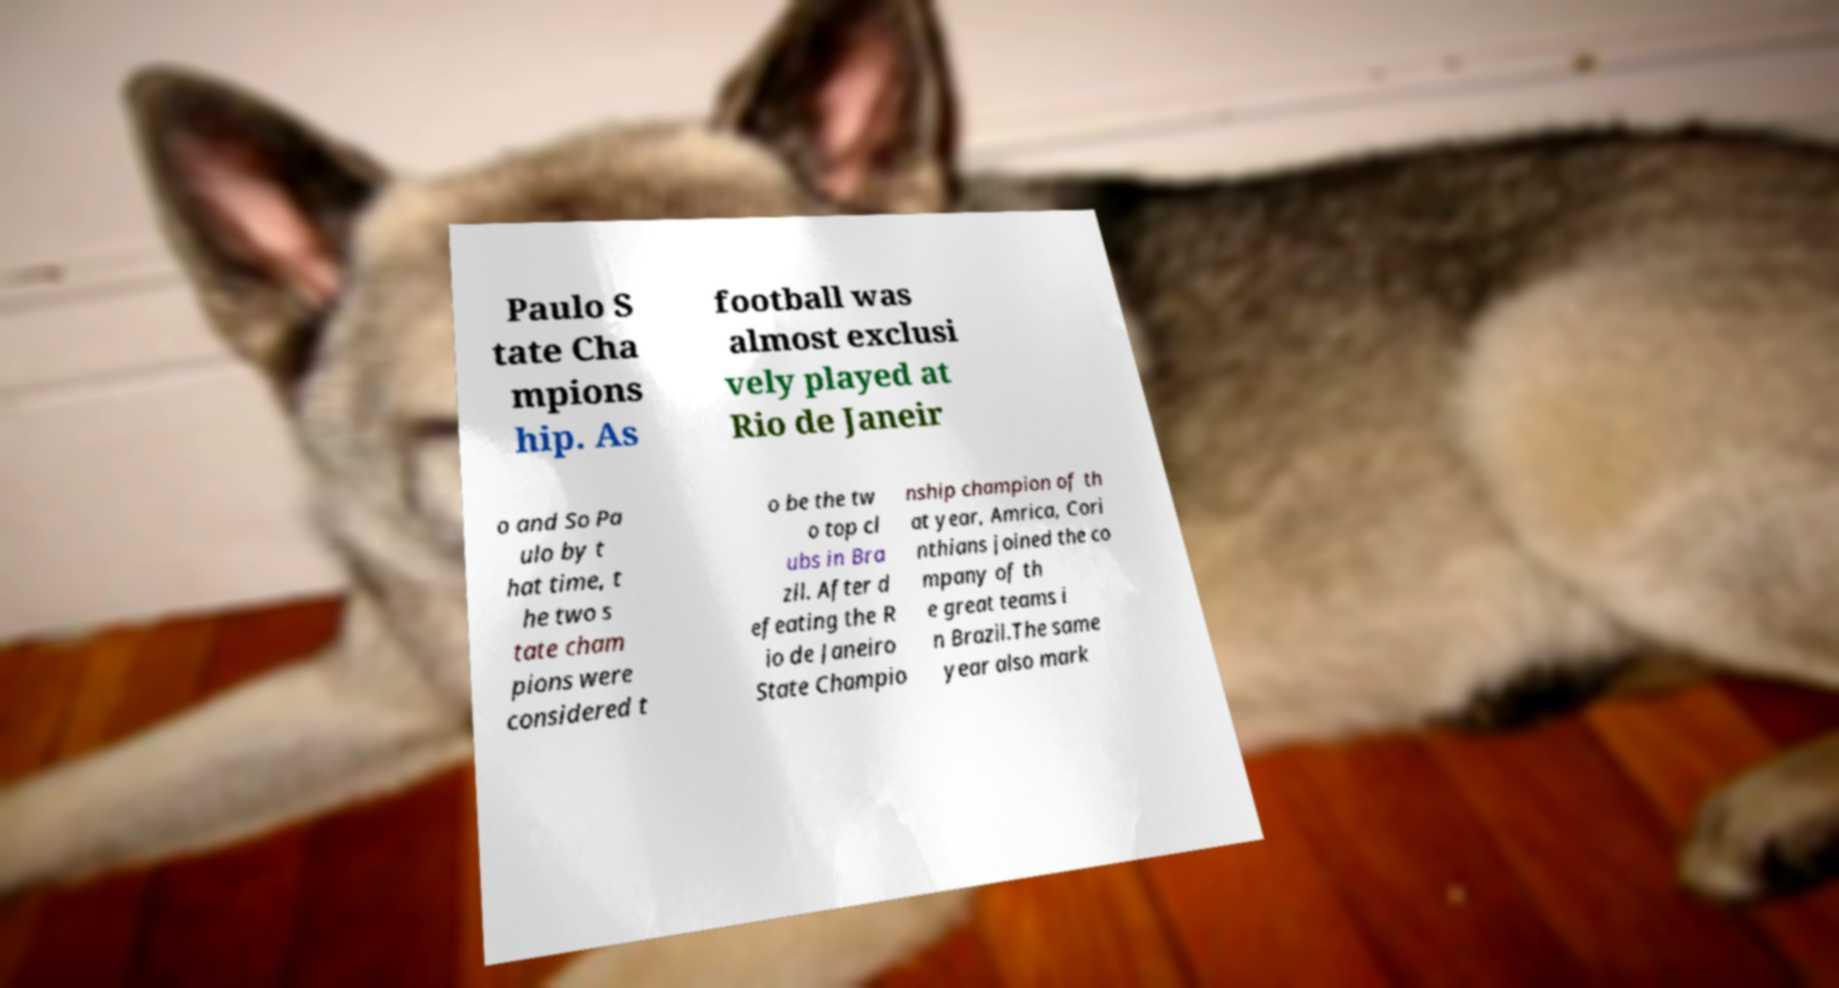Could you extract and type out the text from this image? Paulo S tate Cha mpions hip. As football was almost exclusi vely played at Rio de Janeir o and So Pa ulo by t hat time, t he two s tate cham pions were considered t o be the tw o top cl ubs in Bra zil. After d efeating the R io de Janeiro State Champio nship champion of th at year, Amrica, Cori nthians joined the co mpany of th e great teams i n Brazil.The same year also mark 